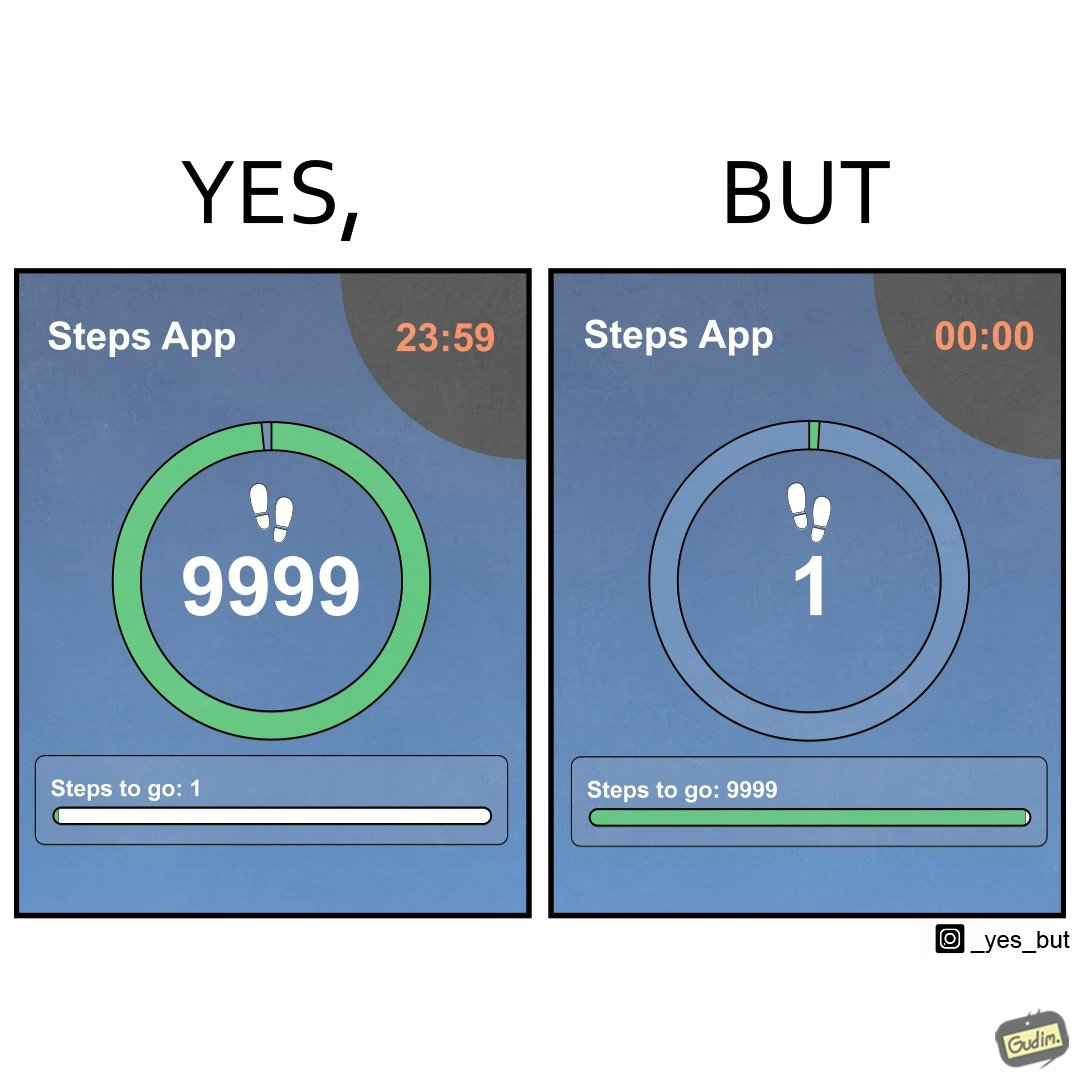Why is this image considered satirical? The images are funny since they show how close the user is to hitting his daily target of 10000 steps, but as soon as it is midnight, the step counter resets and the user misses his daily target by one step. Once the clock resets he is 9999 steps away from his target 